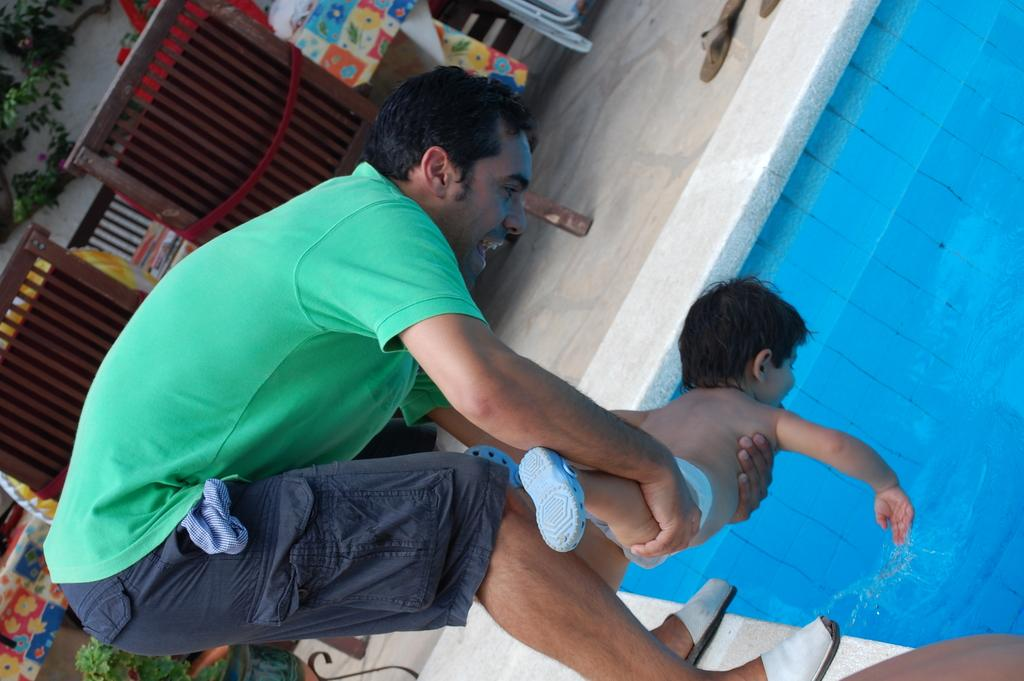What is the main subject of the image? There is a man in the image. Can you describe what the man is wearing? The man is wearing a green t-shirt and shorts. What is the man doing in the image? The man is holding a baby. Where are they located in the image? They are in a pool. What other objects or structures can be seen in the image? There is a dining table in the image, and plants are behind the dining table. What type of truck is parked behind the plants in the image? There is no truck present in the image; only a dining table and plants are visible behind it. 